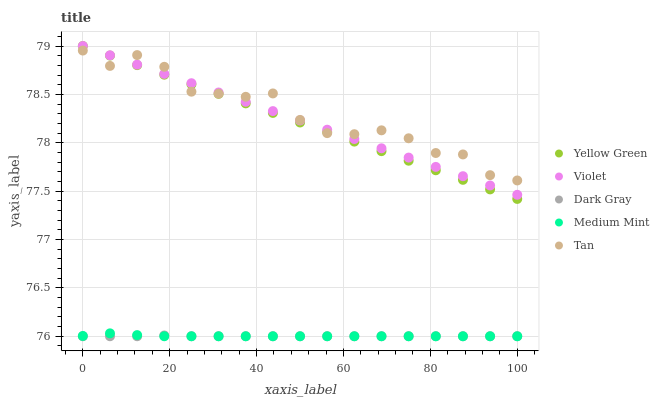Does Dark Gray have the minimum area under the curve?
Answer yes or no. Yes. Does Tan have the maximum area under the curve?
Answer yes or no. Yes. Does Medium Mint have the minimum area under the curve?
Answer yes or no. No. Does Medium Mint have the maximum area under the curve?
Answer yes or no. No. Is Yellow Green the smoothest?
Answer yes or no. Yes. Is Tan the roughest?
Answer yes or no. Yes. Is Medium Mint the smoothest?
Answer yes or no. No. Is Medium Mint the roughest?
Answer yes or no. No. Does Dark Gray have the lowest value?
Answer yes or no. Yes. Does Tan have the lowest value?
Answer yes or no. No. Does Violet have the highest value?
Answer yes or no. Yes. Does Medium Mint have the highest value?
Answer yes or no. No. Is Medium Mint less than Tan?
Answer yes or no. Yes. Is Yellow Green greater than Dark Gray?
Answer yes or no. Yes. Does Yellow Green intersect Tan?
Answer yes or no. Yes. Is Yellow Green less than Tan?
Answer yes or no. No. Is Yellow Green greater than Tan?
Answer yes or no. No. Does Medium Mint intersect Tan?
Answer yes or no. No. 